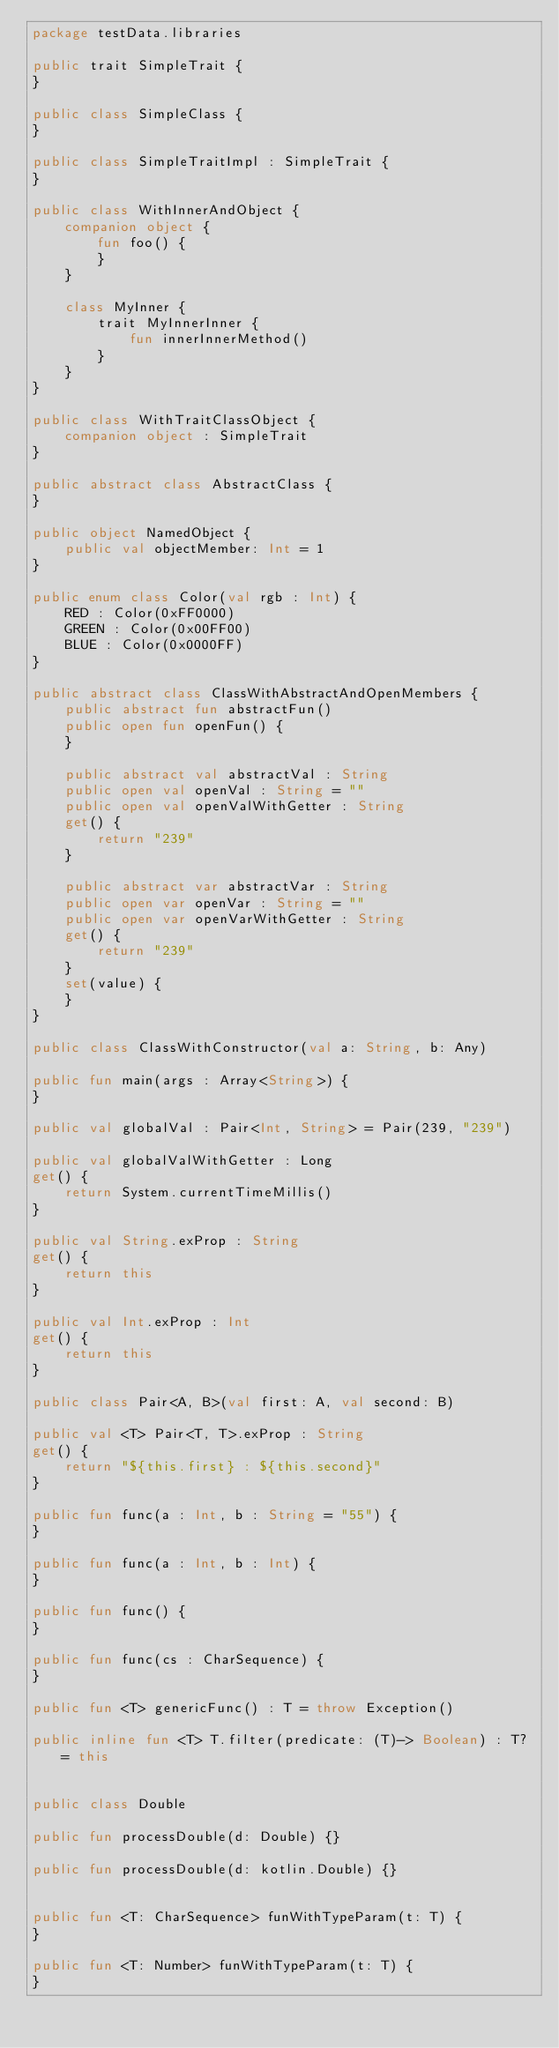<code> <loc_0><loc_0><loc_500><loc_500><_Kotlin_>package testData.libraries

public trait SimpleTrait {
}

public class SimpleClass {
}

public class SimpleTraitImpl : SimpleTrait {
}

public class WithInnerAndObject {
    companion object {
        fun foo() {
        }
    }

    class MyInner {
        trait MyInnerInner {
            fun innerInnerMethod()
        }
    }
}

public class WithTraitClassObject {
    companion object : SimpleTrait
}

public abstract class AbstractClass {
}

public object NamedObject {
    public val objectMember: Int = 1
}

public enum class Color(val rgb : Int) {
    RED : Color(0xFF0000)
    GREEN : Color(0x00FF00)
    BLUE : Color(0x0000FF)
}

public abstract class ClassWithAbstractAndOpenMembers {
    public abstract fun abstractFun()
    public open fun openFun() {
    }

    public abstract val abstractVal : String
    public open val openVal : String = ""
    public open val openValWithGetter : String
    get() {
        return "239"
    }

    public abstract var abstractVar : String
    public open var openVar : String = ""
    public open var openVarWithGetter : String
    get() {
        return "239"
    }
    set(value) {
    }
}

public class ClassWithConstructor(val a: String, b: Any)

public fun main(args : Array<String>) {
}

public val globalVal : Pair<Int, String> = Pair(239, "239")

public val globalValWithGetter : Long
get() {
    return System.currentTimeMillis()
}

public val String.exProp : String
get() {
    return this
}

public val Int.exProp : Int
get() {
    return this
}

public class Pair<A, B>(val first: A, val second: B)

public val <T> Pair<T, T>.exProp : String
get() {
    return "${this.first} : ${this.second}"
}

public fun func(a : Int, b : String = "55") {
}

public fun func(a : Int, b : Int) {
}

public fun func() {
}

public fun func(cs : CharSequence) {
}

public fun <T> genericFunc() : T = throw Exception()

public inline fun <T> T.filter(predicate: (T)-> Boolean) : T? = this


public class Double

public fun processDouble(d: Double) {}

public fun processDouble(d: kotlin.Double) {}


public fun <T: CharSequence> funWithTypeParam(t: T) {
}

public fun <T: Number> funWithTypeParam(t: T) {
}
</code> 